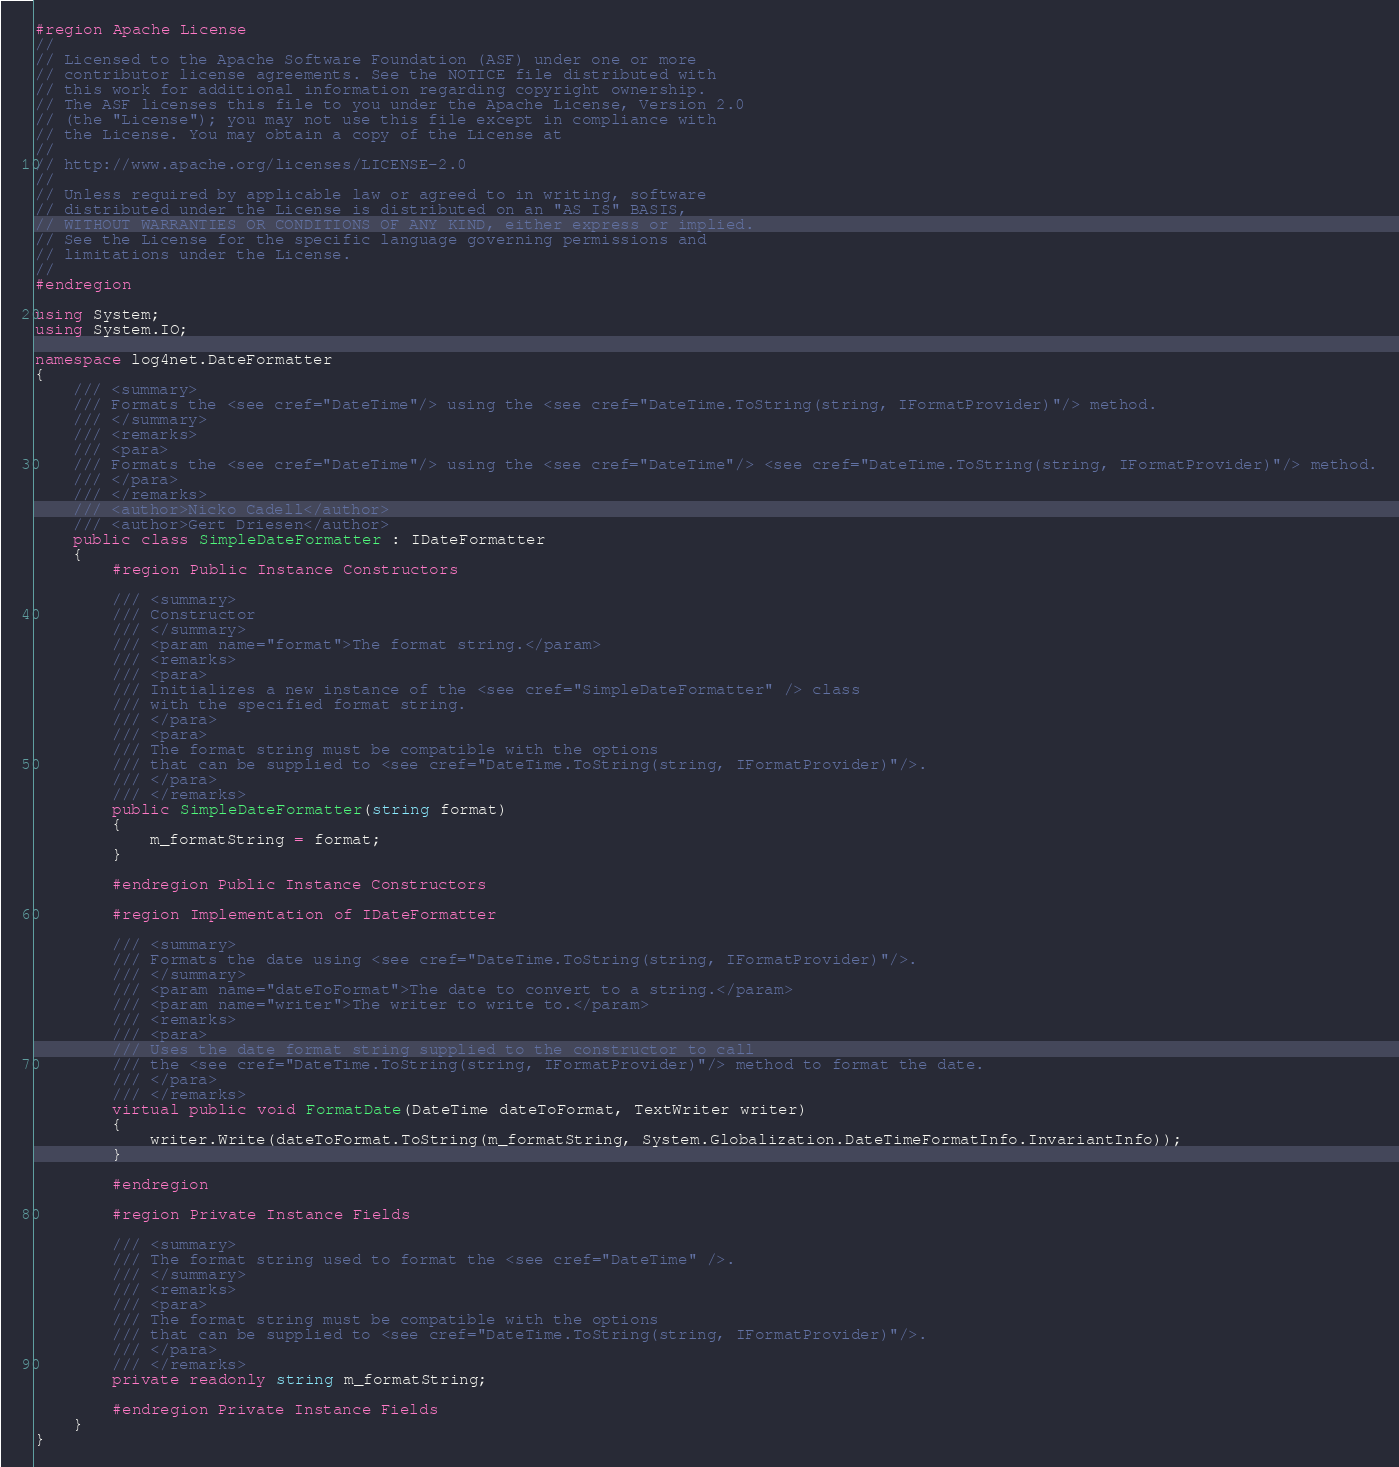<code> <loc_0><loc_0><loc_500><loc_500><_C#_>#region Apache License
//
// Licensed to the Apache Software Foundation (ASF) under one or more 
// contributor license agreements. See the NOTICE file distributed with
// this work for additional information regarding copyright ownership. 
// The ASF licenses this file to you under the Apache License, Version 2.0
// (the "License"); you may not use this file except in compliance with 
// the License. You may obtain a copy of the License at
//
// http://www.apache.org/licenses/LICENSE-2.0
//
// Unless required by applicable law or agreed to in writing, software
// distributed under the License is distributed on an "AS IS" BASIS,
// WITHOUT WARRANTIES OR CONDITIONS OF ANY KIND, either express or implied.
// See the License for the specific language governing permissions and
// limitations under the License.
//
#endregion

using System;
using System.IO;

namespace log4net.DateFormatter
{
	/// <summary>
	/// Formats the <see cref="DateTime"/> using the <see cref="DateTime.ToString(string, IFormatProvider)"/> method.
	/// </summary>
	/// <remarks>
	/// <para>
	/// Formats the <see cref="DateTime"/> using the <see cref="DateTime"/> <see cref="DateTime.ToString(string, IFormatProvider)"/> method.
	/// </para>
	/// </remarks>
	/// <author>Nicko Cadell</author>
	/// <author>Gert Driesen</author>
	public class SimpleDateFormatter : IDateFormatter
	{
		#region Public Instance Constructors

		/// <summary>
		/// Constructor
		/// </summary>
		/// <param name="format">The format string.</param>
		/// <remarks>
		/// <para>
		/// Initializes a new instance of the <see cref="SimpleDateFormatter" /> class 
		/// with the specified format string.
		/// </para>
		/// <para>
		/// The format string must be compatible with the options
		/// that can be supplied to <see cref="DateTime.ToString(string, IFormatProvider)"/>.
		/// </para>
		/// </remarks>
		public SimpleDateFormatter(string format)
		{
			m_formatString = format;
		}

		#endregion Public Instance Constructors

		#region Implementation of IDateFormatter

		/// <summary>
		/// Formats the date using <see cref="DateTime.ToString(string, IFormatProvider)"/>.
		/// </summary>
		/// <param name="dateToFormat">The date to convert to a string.</param>
		/// <param name="writer">The writer to write to.</param>
		/// <remarks>
		/// <para>
		/// Uses the date format string supplied to the constructor to call
		/// the <see cref="DateTime.ToString(string, IFormatProvider)"/> method to format the date.
		/// </para>
		/// </remarks>
		virtual public void FormatDate(DateTime dateToFormat, TextWriter writer)
		{
			writer.Write(dateToFormat.ToString(m_formatString, System.Globalization.DateTimeFormatInfo.InvariantInfo));
		}

		#endregion

		#region Private Instance Fields

		/// <summary>
		/// The format string used to format the <see cref="DateTime" />.
		/// </summary>
		/// <remarks>
		/// <para>
		/// The format string must be compatible with the options
		/// that can be supplied to <see cref="DateTime.ToString(string, IFormatProvider)"/>.
		/// </para>
		/// </remarks>
		private readonly string m_formatString;

		#endregion Private Instance Fields
	}
}
</code> 